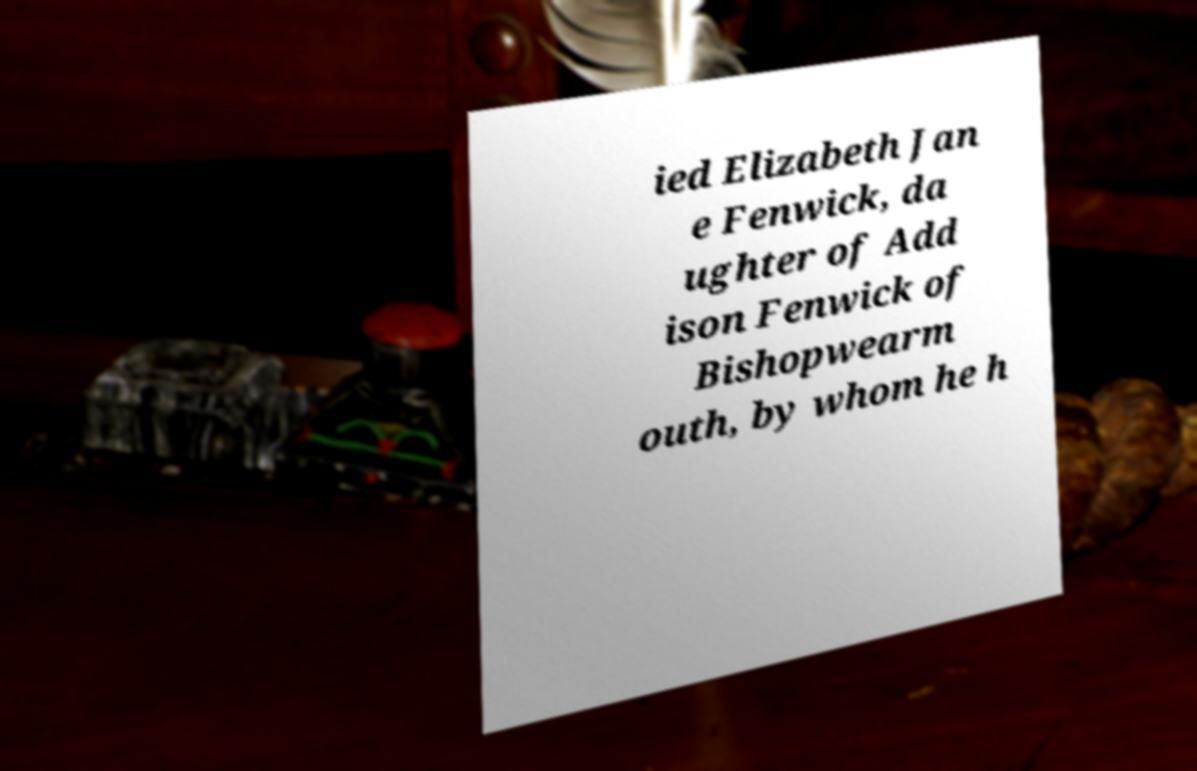There's text embedded in this image that I need extracted. Can you transcribe it verbatim? ied Elizabeth Jan e Fenwick, da ughter of Add ison Fenwick of Bishopwearm outh, by whom he h 